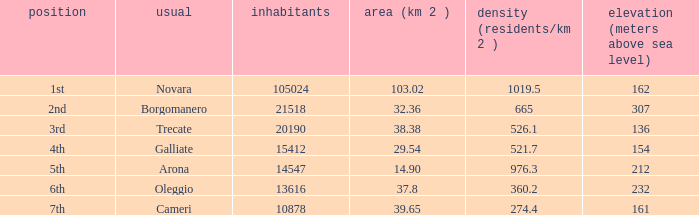Help me parse the entirety of this table. {'header': ['position', 'usual', 'inhabitants', 'area (km 2 )', 'density (residents/km 2 )', 'elevation (meters above sea level)'], 'rows': [['1st', 'Novara', '105024', '103.02', '1019.5', '162'], ['2nd', 'Borgomanero', '21518', '32.36', '665', '307'], ['3rd', 'Trecate', '20190', '38.38', '526.1', '136'], ['4th', 'Galliate', '15412', '29.54', '521.7', '154'], ['5th', 'Arona', '14547', '14.90', '976.3', '212'], ['6th', 'Oleggio', '13616', '37.8', '360.2', '232'], ['7th', 'Cameri', '10878', '39.65', '274.4', '161']]} What is the minimum altitude (mslm) in all the commons? 136.0. 